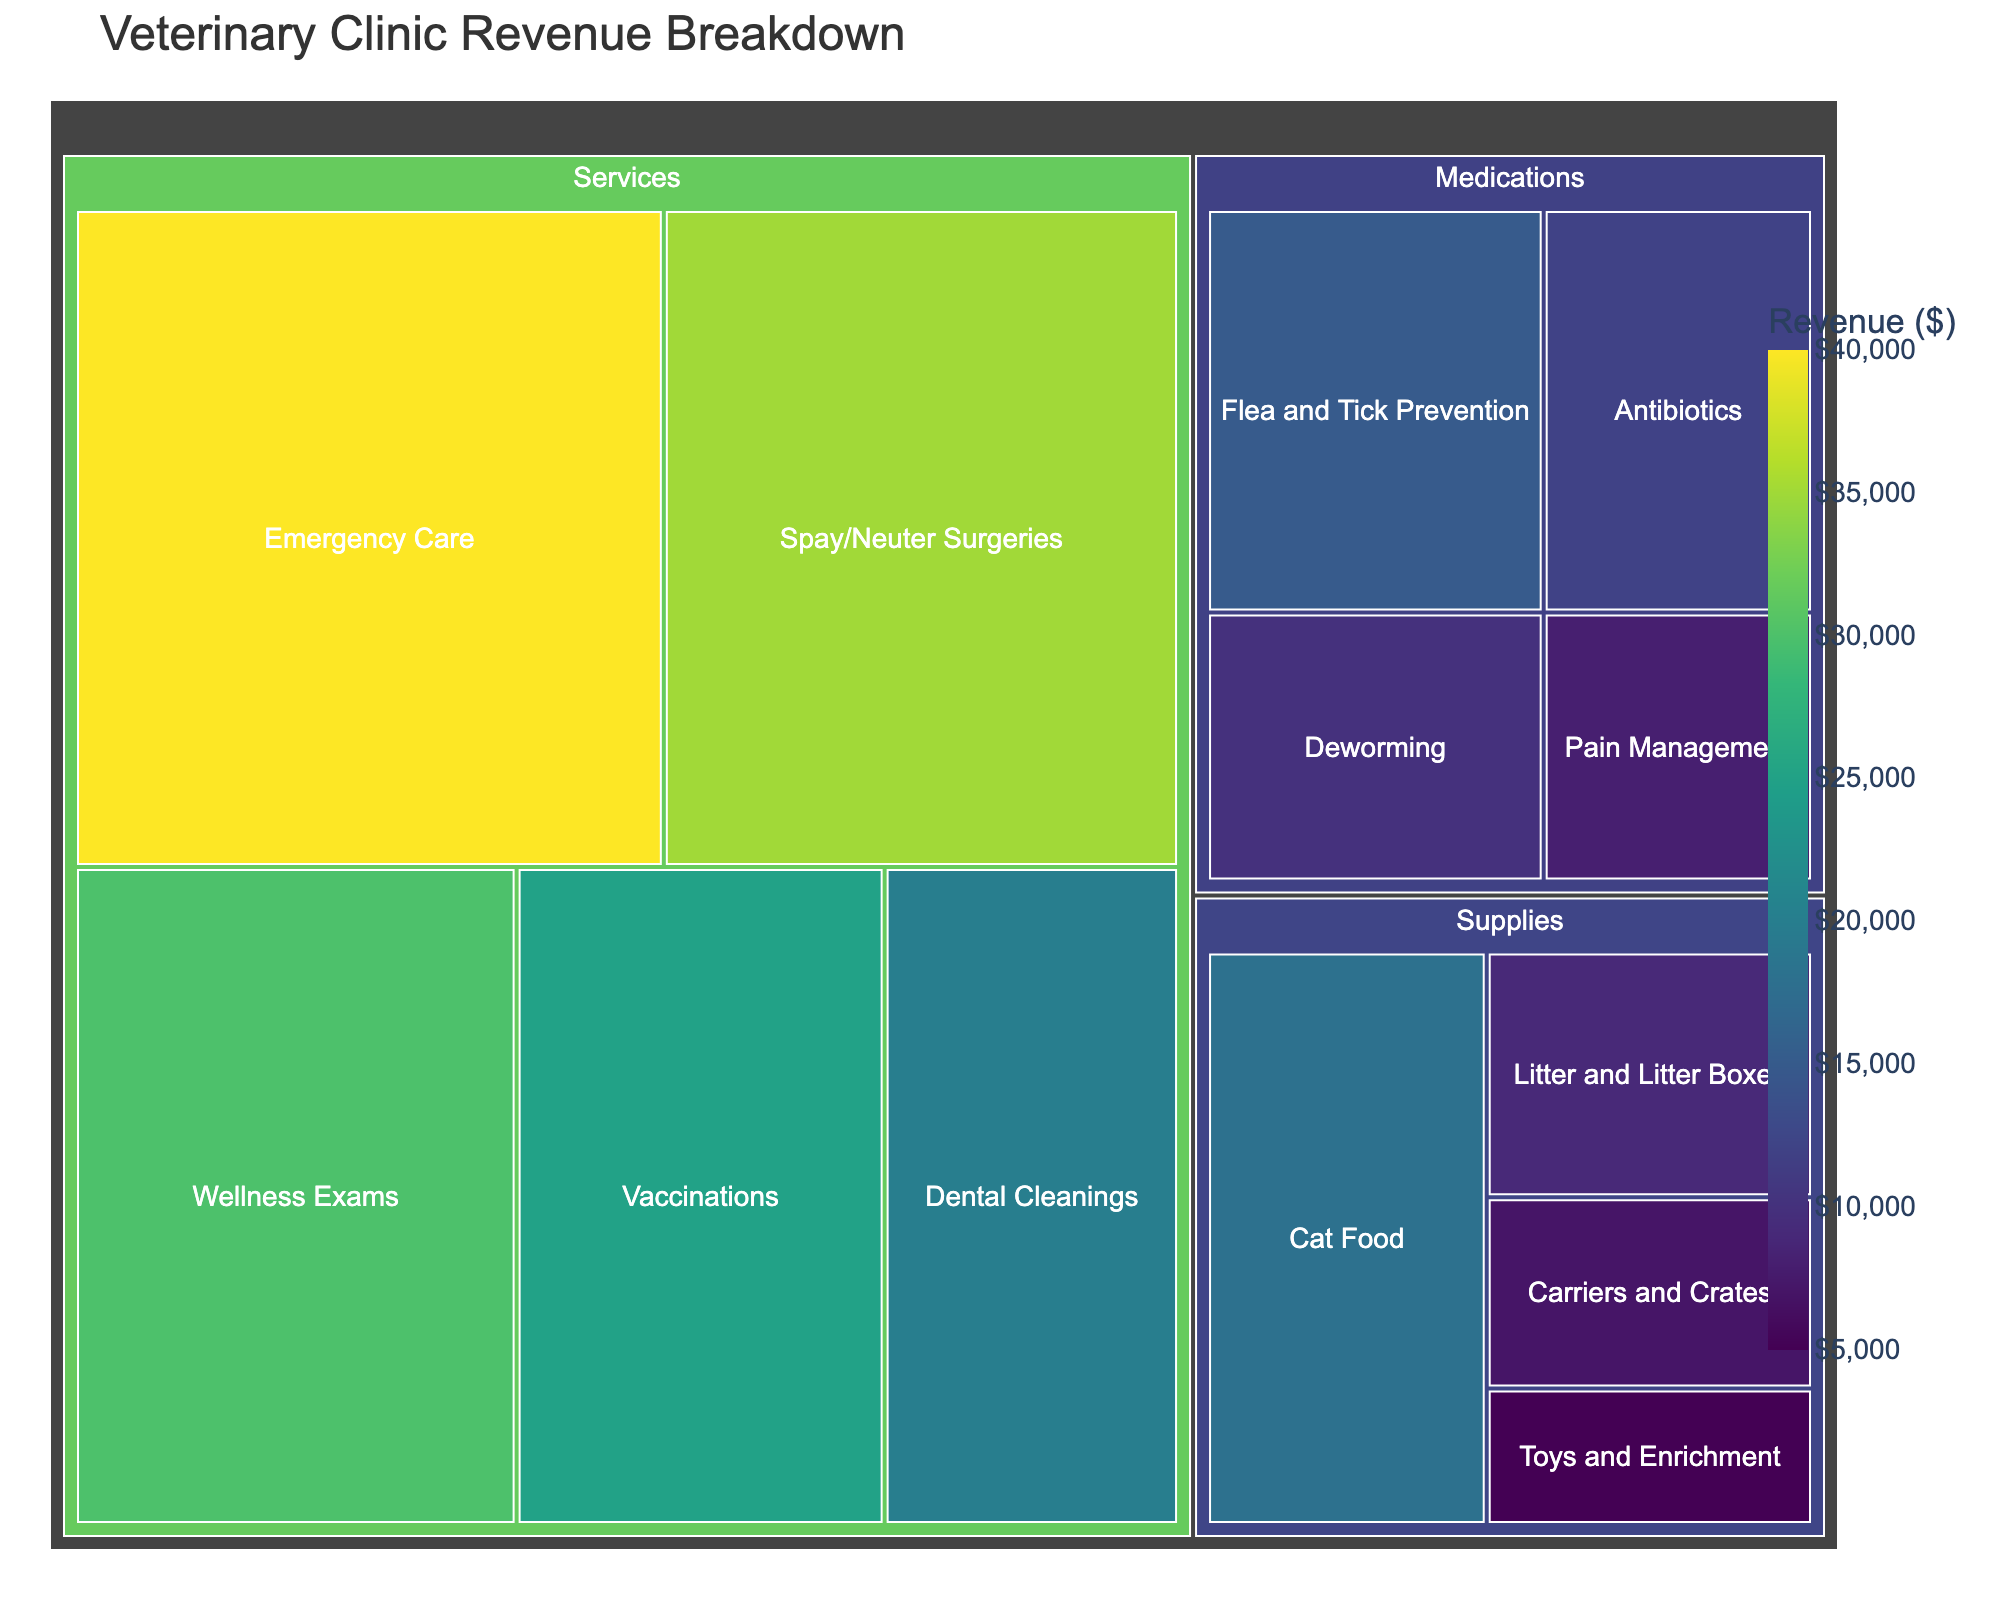What's the highest revenue subcategory in the figure? To determine this, locate the subcategory box with the largest area and highest corresponding revenue value.
Answer: Emergency Care What is the total revenue generated by Services? First, identify the individual revenue values within the Services category: Vaccinations ($25,000), Wellness Exams ($30,000), Dental Cleanings ($20,000), Spay/Neuter Surgeries ($35,000), and Emergency Care ($40,000). Sum these values: $25,000 + $30,000 + $20,000 + $35,000 + $40,000 = $150,000.
Answer: $150,000 Which subcategory in Medications generates the least revenue? Look at the subcategories within Medications and identify the one with the smallest revenue: Flea and Tick Prevention ($15,000), Deworming ($10,000), Antibiotics ($12,000), Pain Management ($8,000). The smallest revenue is $8,000.
Answer: Pain Management By how much does the revenue from Spay/Neuter Surgeries exceed that from Dental Cleanings? Compare the revenue values for Spay/Neuter Surgeries ($35,000) and Dental Cleanings ($20,000). Calculate the difference: $35,000 - $20,000 = $15,000.
Answer: $15,000 Which category, Medications or Supplies, generates more revenue and by how much? Sum the revenues for each category and compare them. Medications: Flea and Tick Prevention ($15,000) + Deworming ($10,000) + Antibiotics ($12,000) + Pain Management ($8,000) = $45,000. Supplies: Cat Food ($18,000) + Litter and Litter Boxes ($9,000) + Carriers and Crates ($7,000) + Toys and Enrichment ($5,000) = $39,000. Medications generate $45,000 - $39,000 = $6,000 more.
Answer: Medications, $6,000 What percentage of the total revenue does Emergency Care contribute? First, find the total revenue: $25,000 (Vaccinations) + $30,000 (Wellness Exams) + $20,000 (Dental Cleanings) + $35,000 (Spay/Neuter Surgeries) + $40,000 (Emergency Care) + $15,000 (Flea and Tick Prevention) + $10,000 (Deworming) + $12,000 (Antibiotics) + $8,000 (Pain Management) + $18,000 (Cat Food) + $9,000 (Litter and Litter Boxes) + $7,000 (Carriers and Crates) + $5,000 (Toys and Enrichment) = $264,000. Then calculate the percentage for Emergency Care: ($40,000 / $264,000) * 100 ≈ 15.15%.
Answer: Approximately 15.15% Which has a larger revenue: Cat Food or Flea and Tick Prevention? Compare the revenue values for Cat Food ($18,000) and Flea and Tick Prevention ($15,000). Cat Food has a higher revenue.
Answer: Cat Food What's the combined revenue for subcategories related to feline health (including Wellness Exams and Spay/Neuter Surgeries)? Sum the revenues of Wellness Exams ($30,000) and Spay/Neuter Surgeries ($35,000): $30,000 + $35,000 = $65,000.
Answer: $65,000 How many subcategories have a revenue of $20,000 or more? Identify and count subcategories with revenue equal to or greater than $20,000: Vaccinations ($25,000), Wellness Exams ($30,000), Dental Cleanings ($20,000), Spay/Neuter Surgeries ($35,000), Emergency Care ($40,000). There are 5 subcategories.
Answer: 5 